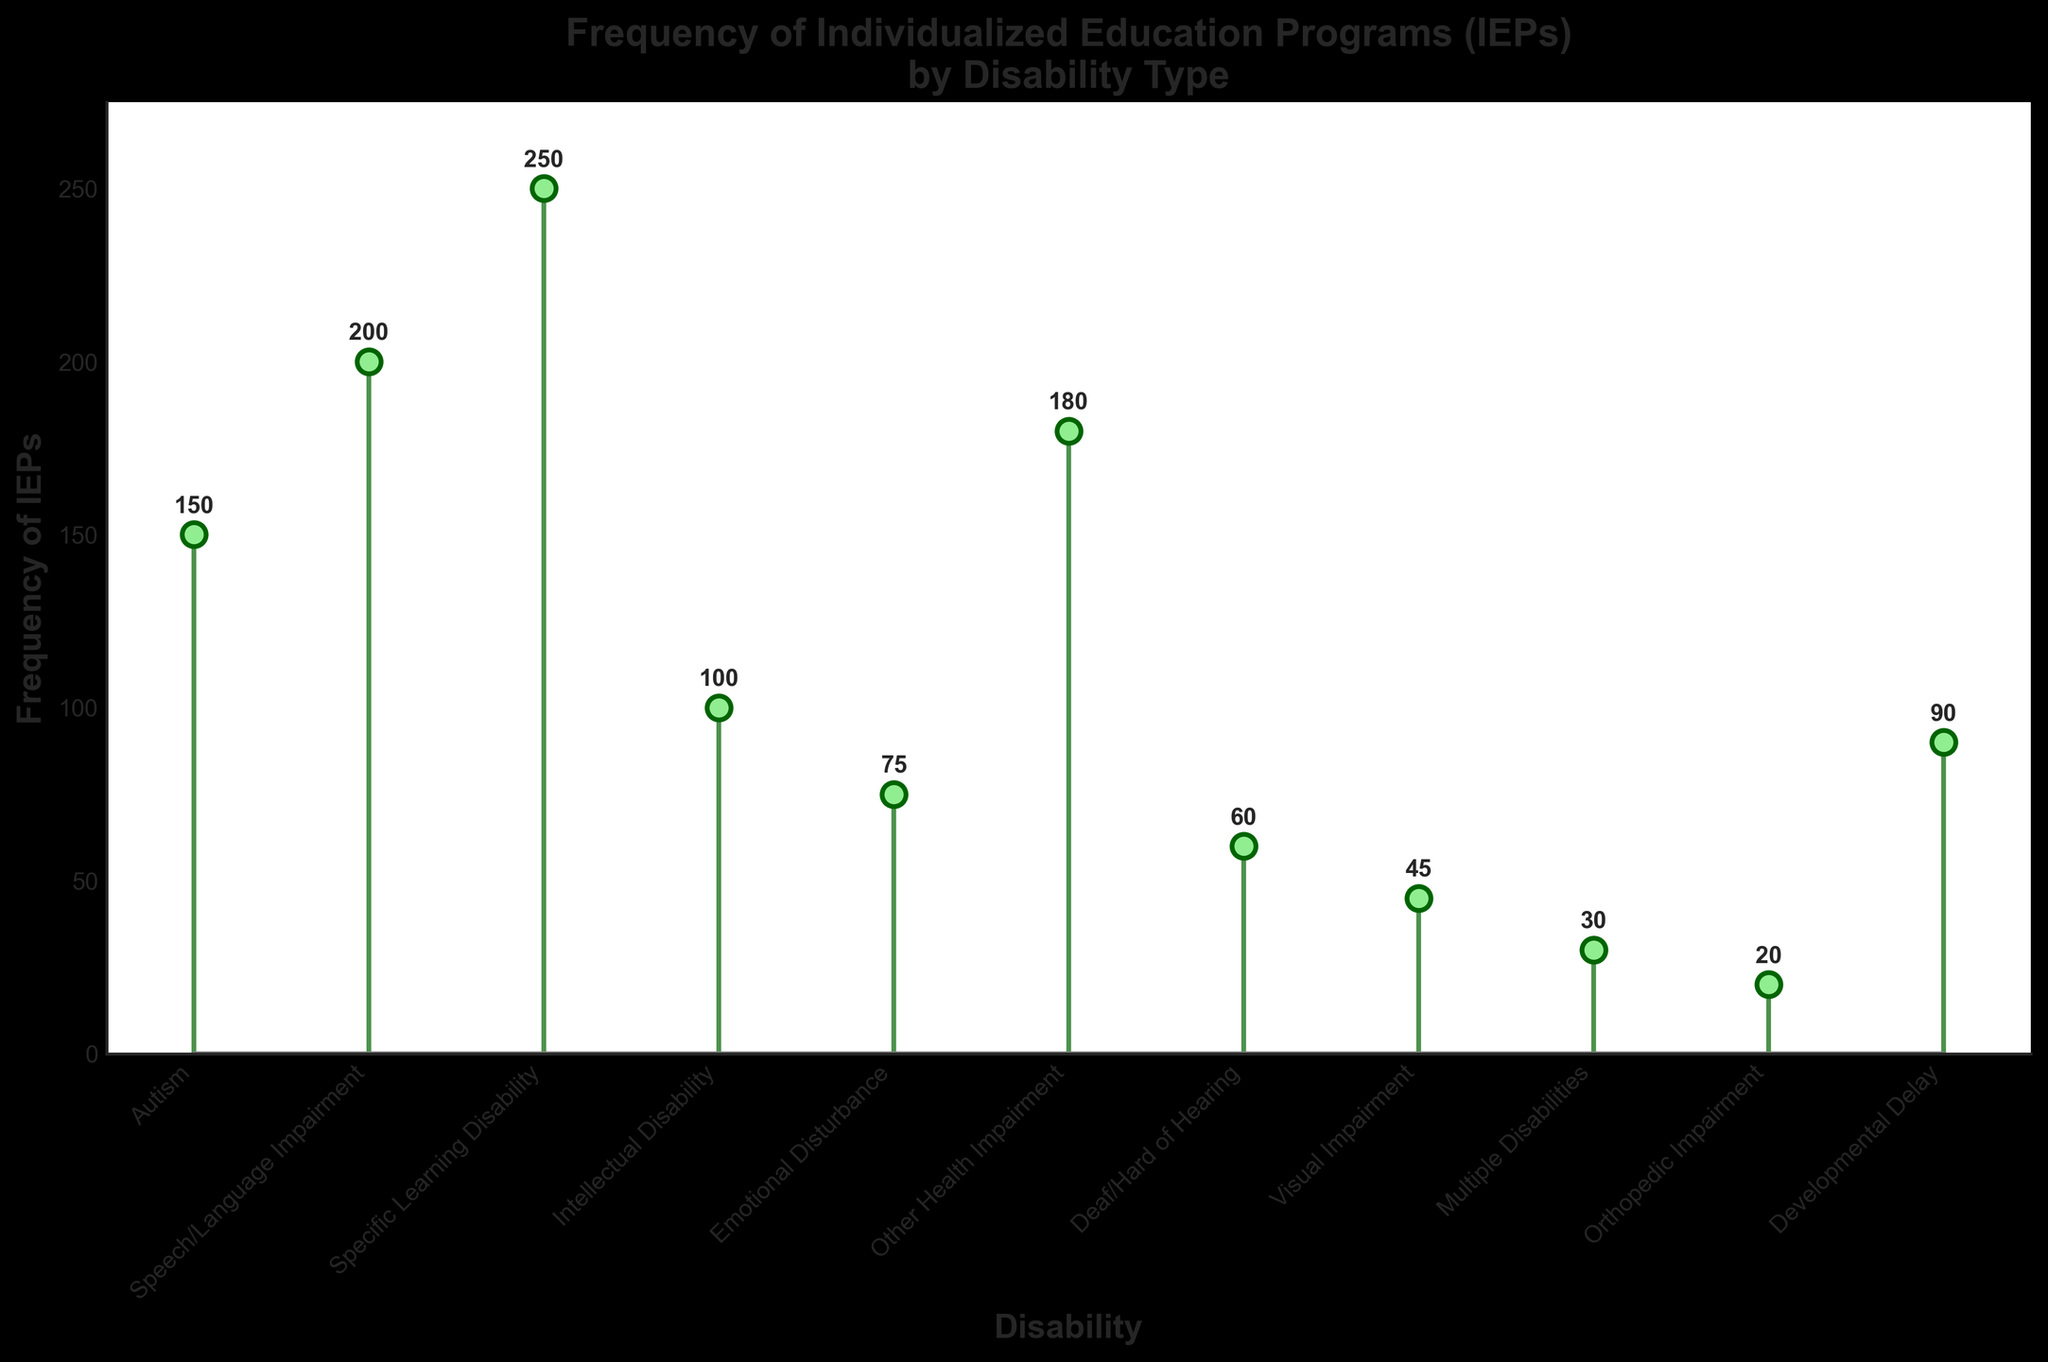What's the title of the figure? The title is located at the top of the figure and provides a summary of what the figure is about.
Answer: Frequency of Individualized Education Programs (IEPs) by Disability Type How many disabilities are listed in the figure? Count the number of unique disabilities shown along the x-axis.
Answer: 11 Which disability has the highest frequency of IEPs? Identify the tallest stem line on the plot and read the associated disability label on the x-axis.
Answer: Specific Learning Disability What is the frequency of IEPs for Autism? Locate the stem line for Autism and read the corresponding value above the line.
Answer: 150 What's the total number of IEPs implemented for Emotional Disturbance and Visual Impairment combined? Find the frequencies for Emotional Disturbance and Visual Impairment, then add them together: 75 + 45.
Answer: 120 Which disability has fewer IEPs: Orthopedic Impairment or Developmental Delay? Compare the lengths of the stem lines for Orthopedic Impairment and Developmental Delay.
Answer: Orthopedic Impairment What's the difference in the frequency of IEPs between Speech/Language Impairment and Other Health Impairment? Subtract the frequency of Other Health Impairment from Speech/Language Impairment: 200 - 180.
Answer: 20 What is the average frequency of IEPs across all disabilities? Add all the IEP frequencies and divide by the number of disabilities: (150 + 200 + 250 + 100 + 75 + 180 + 60 + 45 + 30 + 20 + 90) / 11.
Answer: 109 Which disability has the lowest frequency of IEPs? Identify the shortest stem line on the plot and read the corresponding disability label on the x-axis.
Answer: Orthopedic Impairment What is the median frequency of IEPs across the listed disabilities? List all frequencies in ascending order and find the middle value: (20, 30, 45, 60, 75, 90, 100, 150, 180, 200, 250). The median is the 6th value.
Answer: 90 